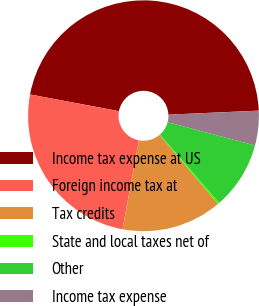Convert chart. <chart><loc_0><loc_0><loc_500><loc_500><pie_chart><fcel>Income tax expense at US<fcel>Foreign income tax at<fcel>Tax credits<fcel>State and local taxes net of<fcel>Other<fcel>Income tax expense<nl><fcel>46.34%<fcel>25.06%<fcel>14.07%<fcel>0.24%<fcel>9.46%<fcel>4.85%<nl></chart> 